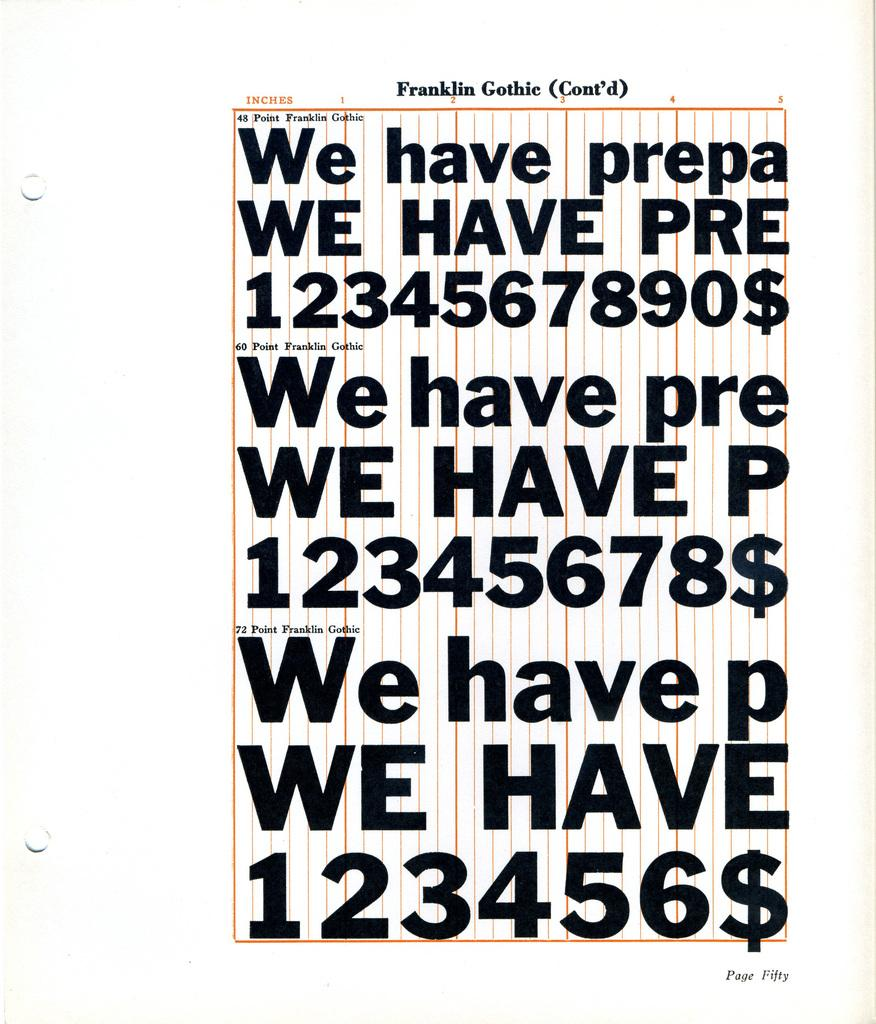<image>
Render a clear and concise summary of the photo. A page displays the Franklin Gothie font with letters and numbers. 